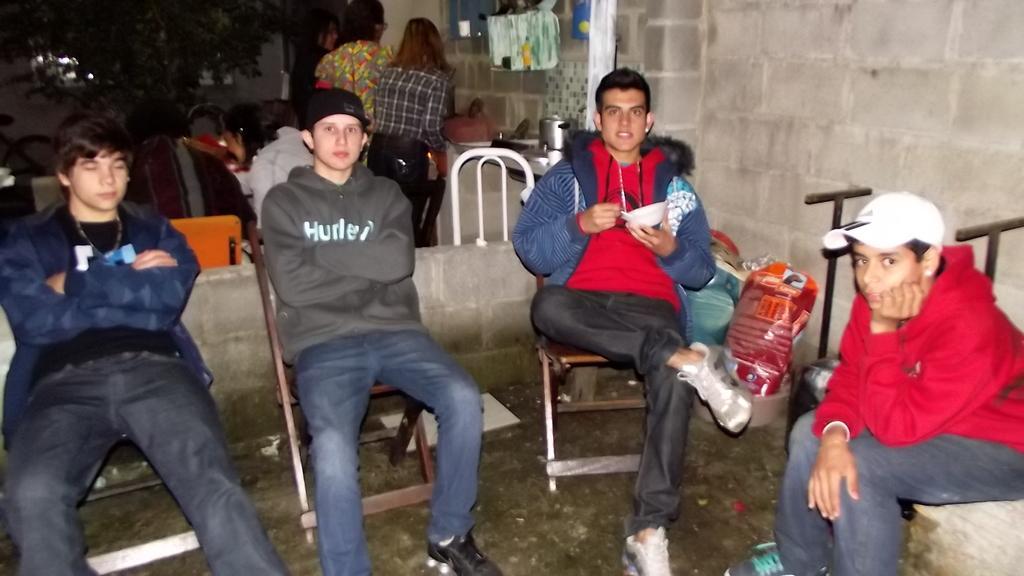Please provide a concise description of this image. In this image we can see few people sitting on the chairs a person is holding a bowl and there is a carry bag and few objects on the floor beside the person and in the background there are two persons standing near the wall and there are few objects on the shelf to the wall. 